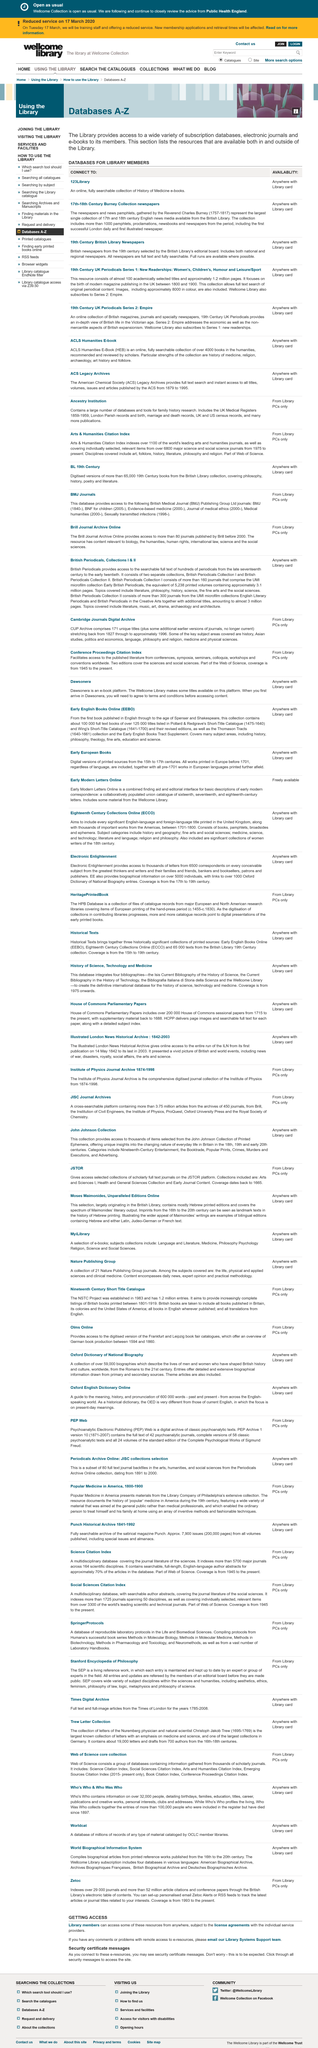Give some essential details in this illustration. There are more than 1000 pamphlets in the collection. The Reverend Charles Burney was the person who gathered the newspapers and news pamphlets. The Burney Collection contains newspapers from the 17th and 18th centuries. 